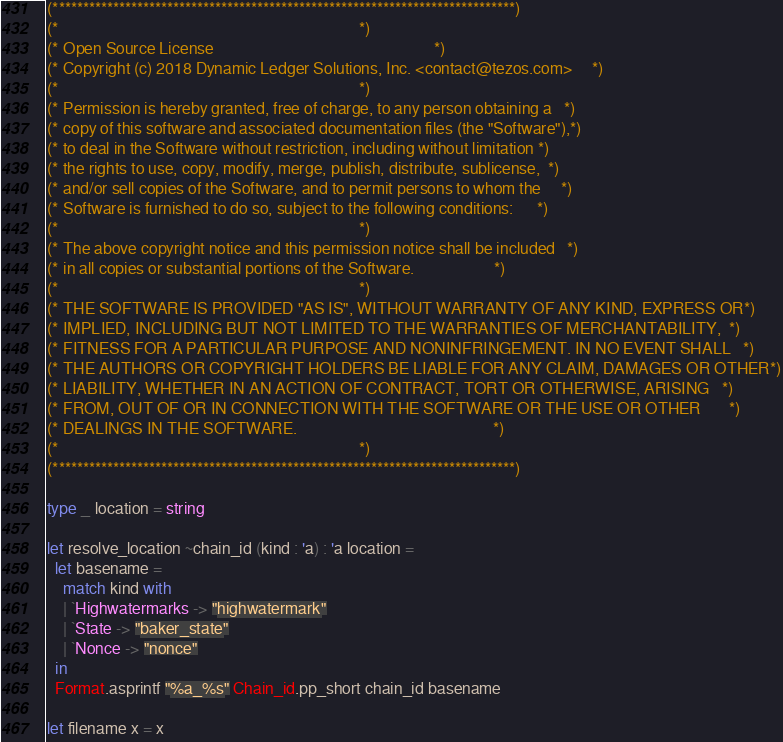Convert code to text. <code><loc_0><loc_0><loc_500><loc_500><_OCaml_>(*****************************************************************************)
(*                                                                           *)
(* Open Source License                                                       *)
(* Copyright (c) 2018 Dynamic Ledger Solutions, Inc. <contact@tezos.com>     *)
(*                                                                           *)
(* Permission is hereby granted, free of charge, to any person obtaining a   *)
(* copy of this software and associated documentation files (the "Software"),*)
(* to deal in the Software without restriction, including without limitation *)
(* the rights to use, copy, modify, merge, publish, distribute, sublicense,  *)
(* and/or sell copies of the Software, and to permit persons to whom the     *)
(* Software is furnished to do so, subject to the following conditions:      *)
(*                                                                           *)
(* The above copyright notice and this permission notice shall be included   *)
(* in all copies or substantial portions of the Software.                    *)
(*                                                                           *)
(* THE SOFTWARE IS PROVIDED "AS IS", WITHOUT WARRANTY OF ANY KIND, EXPRESS OR*)
(* IMPLIED, INCLUDING BUT NOT LIMITED TO THE WARRANTIES OF MERCHANTABILITY,  *)
(* FITNESS FOR A PARTICULAR PURPOSE AND NONINFRINGEMENT. IN NO EVENT SHALL   *)
(* THE AUTHORS OR COPYRIGHT HOLDERS BE LIABLE FOR ANY CLAIM, DAMAGES OR OTHER*)
(* LIABILITY, WHETHER IN AN ACTION OF CONTRACT, TORT OR OTHERWISE, ARISING   *)
(* FROM, OUT OF OR IN CONNECTION WITH THE SOFTWARE OR THE USE OR OTHER       *)
(* DEALINGS IN THE SOFTWARE.                                                 *)
(*                                                                           *)
(*****************************************************************************)

type _ location = string

let resolve_location ~chain_id (kind : 'a) : 'a location =
  let basename =
    match kind with
    | `Highwatermarks -> "highwatermark"
    | `State -> "baker_state"
    | `Nonce -> "nonce"
  in
  Format.asprintf "%a_%s" Chain_id.pp_short chain_id basename

let filename x = x
</code> 